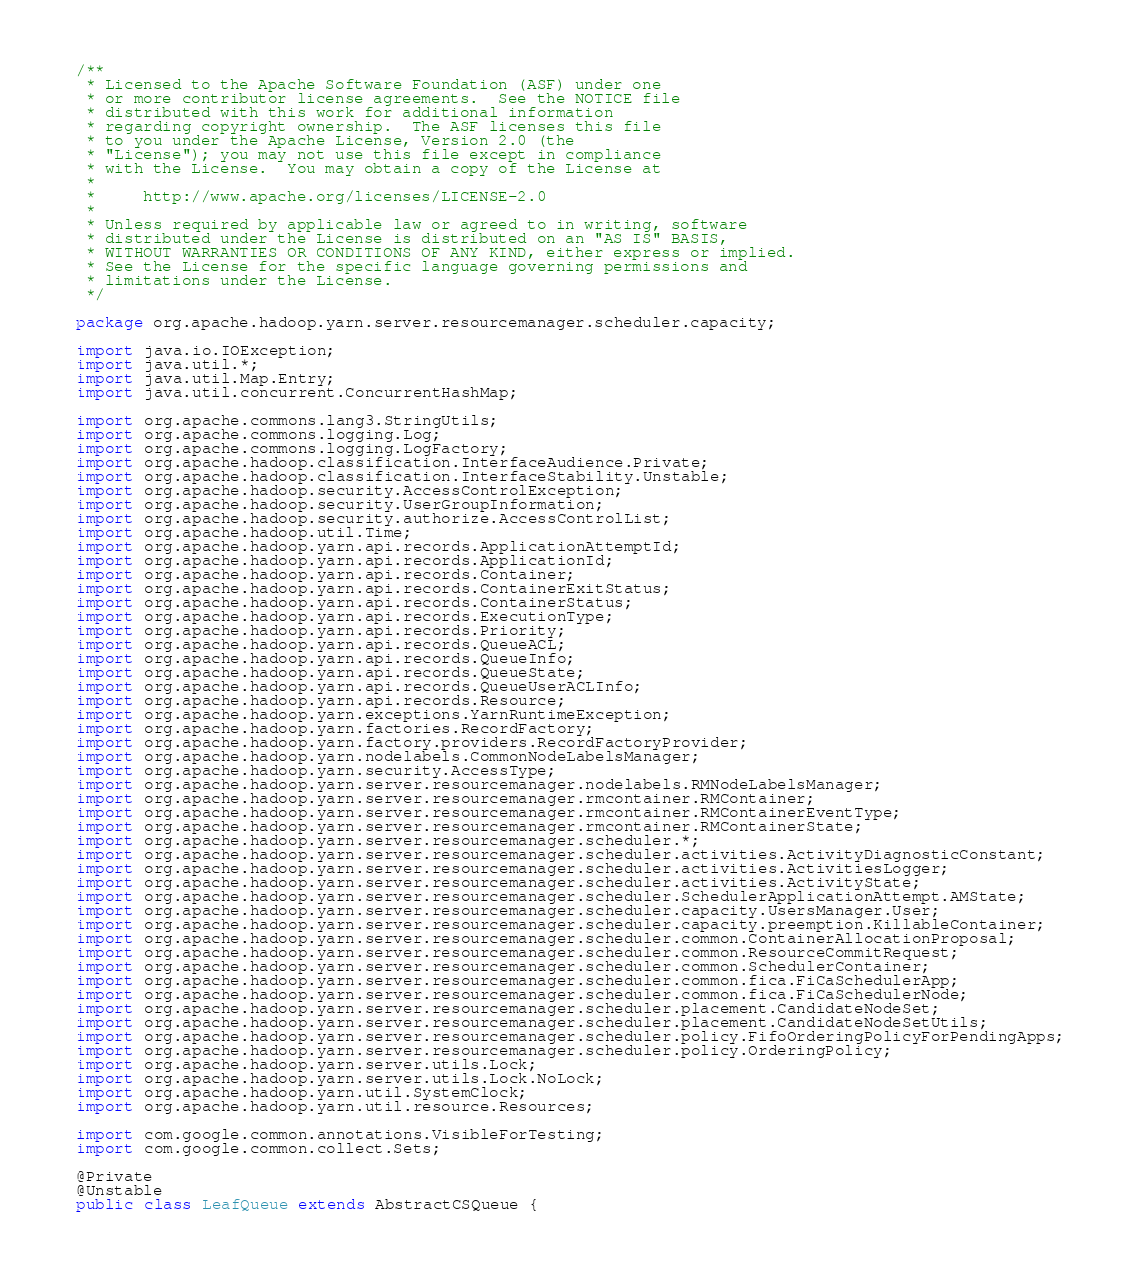Convert code to text. <code><loc_0><loc_0><loc_500><loc_500><_Java_>/**
 * Licensed to the Apache Software Foundation (ASF) under one
 * or more contributor license agreements.  See the NOTICE file
 * distributed with this work for additional information
 * regarding copyright ownership.  The ASF licenses this file
 * to you under the Apache License, Version 2.0 (the
 * "License"); you may not use this file except in compliance
 * with the License.  You may obtain a copy of the License at
 *
 *     http://www.apache.org/licenses/LICENSE-2.0
 *
 * Unless required by applicable law or agreed to in writing, software
 * distributed under the License is distributed on an "AS IS" BASIS,
 * WITHOUT WARRANTIES OR CONDITIONS OF ANY KIND, either express or implied.
 * See the License for the specific language governing permissions and
 * limitations under the License.
 */

package org.apache.hadoop.yarn.server.resourcemanager.scheduler.capacity;

import java.io.IOException;
import java.util.*;
import java.util.Map.Entry;
import java.util.concurrent.ConcurrentHashMap;

import org.apache.commons.lang3.StringUtils;
import org.apache.commons.logging.Log;
import org.apache.commons.logging.LogFactory;
import org.apache.hadoop.classification.InterfaceAudience.Private;
import org.apache.hadoop.classification.InterfaceStability.Unstable;
import org.apache.hadoop.security.AccessControlException;
import org.apache.hadoop.security.UserGroupInformation;
import org.apache.hadoop.security.authorize.AccessControlList;
import org.apache.hadoop.util.Time;
import org.apache.hadoop.yarn.api.records.ApplicationAttemptId;
import org.apache.hadoop.yarn.api.records.ApplicationId;
import org.apache.hadoop.yarn.api.records.Container;
import org.apache.hadoop.yarn.api.records.ContainerExitStatus;
import org.apache.hadoop.yarn.api.records.ContainerStatus;
import org.apache.hadoop.yarn.api.records.ExecutionType;
import org.apache.hadoop.yarn.api.records.Priority;
import org.apache.hadoop.yarn.api.records.QueueACL;
import org.apache.hadoop.yarn.api.records.QueueInfo;
import org.apache.hadoop.yarn.api.records.QueueState;
import org.apache.hadoop.yarn.api.records.QueueUserACLInfo;
import org.apache.hadoop.yarn.api.records.Resource;
import org.apache.hadoop.yarn.exceptions.YarnRuntimeException;
import org.apache.hadoop.yarn.factories.RecordFactory;
import org.apache.hadoop.yarn.factory.providers.RecordFactoryProvider;
import org.apache.hadoop.yarn.nodelabels.CommonNodeLabelsManager;
import org.apache.hadoop.yarn.security.AccessType;
import org.apache.hadoop.yarn.server.resourcemanager.nodelabels.RMNodeLabelsManager;
import org.apache.hadoop.yarn.server.resourcemanager.rmcontainer.RMContainer;
import org.apache.hadoop.yarn.server.resourcemanager.rmcontainer.RMContainerEventType;
import org.apache.hadoop.yarn.server.resourcemanager.rmcontainer.RMContainerState;
import org.apache.hadoop.yarn.server.resourcemanager.scheduler.*;
import org.apache.hadoop.yarn.server.resourcemanager.scheduler.activities.ActivityDiagnosticConstant;
import org.apache.hadoop.yarn.server.resourcemanager.scheduler.activities.ActivitiesLogger;
import org.apache.hadoop.yarn.server.resourcemanager.scheduler.activities.ActivityState;
import org.apache.hadoop.yarn.server.resourcemanager.scheduler.SchedulerApplicationAttempt.AMState;
import org.apache.hadoop.yarn.server.resourcemanager.scheduler.capacity.UsersManager.User;
import org.apache.hadoop.yarn.server.resourcemanager.scheduler.capacity.preemption.KillableContainer;
import org.apache.hadoop.yarn.server.resourcemanager.scheduler.common.ContainerAllocationProposal;
import org.apache.hadoop.yarn.server.resourcemanager.scheduler.common.ResourceCommitRequest;
import org.apache.hadoop.yarn.server.resourcemanager.scheduler.common.SchedulerContainer;
import org.apache.hadoop.yarn.server.resourcemanager.scheduler.common.fica.FiCaSchedulerApp;
import org.apache.hadoop.yarn.server.resourcemanager.scheduler.common.fica.FiCaSchedulerNode;
import org.apache.hadoop.yarn.server.resourcemanager.scheduler.placement.CandidateNodeSet;
import org.apache.hadoop.yarn.server.resourcemanager.scheduler.placement.CandidateNodeSetUtils;
import org.apache.hadoop.yarn.server.resourcemanager.scheduler.policy.FifoOrderingPolicyForPendingApps;
import org.apache.hadoop.yarn.server.resourcemanager.scheduler.policy.OrderingPolicy;
import org.apache.hadoop.yarn.server.utils.Lock;
import org.apache.hadoop.yarn.server.utils.Lock.NoLock;
import org.apache.hadoop.yarn.util.SystemClock;
import org.apache.hadoop.yarn.util.resource.Resources;

import com.google.common.annotations.VisibleForTesting;
import com.google.common.collect.Sets;

@Private
@Unstable
public class LeafQueue extends AbstractCSQueue {</code> 